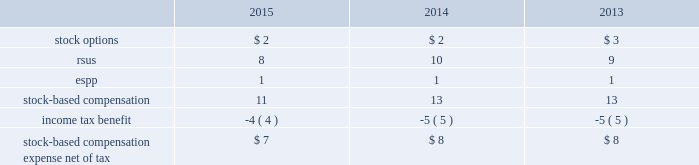Note 9 : stock based compensation the company has granted stock option and restricted stock unit ( 201crsus 201d ) awards to non-employee directors , officers and other key employees of the company pursuant to the terms of its 2007 omnibus equity compensation plan ( the 201c2007 plan 201d ) .
The total aggregate number of shares of common stock that may be issued under the 2007 plan is 15.5 .
As of december 31 , 2015 , 8.4 shares were available for grant under the 2007 plan .
Shares issued under the 2007 plan may be authorized-but-unissued shares of company stock or reacquired shares of company stock , including shares purchased by the company on the open market .
The company recognizes compensation expense for stock awards over the vesting period of the award .
The table presents stock-based compensation expense recorded in operation and maintenance expense in the accompanying consolidated statements of operations for the years ended december 31: .
There were no significant stock-based compensation costs capitalized during the years ended december 31 , 2015 , 2014 and 2013 .
The cost of services received from employees in exchange for the issuance of stock options and restricted stock awards is measured based on the grant date fair value of the awards issued .
The value of stock options and rsus awards at the date of the grant is amortized through expense over the three-year service period .
All awards granted in 2015 , 2014 and 2013 are classified as equity .
The company receives a tax deduction based on the intrinsic value of the award at the exercise date for stock options and the distribution date for rsus .
For each award , throughout the requisite service period , the company recognizes the tax benefits , which have been included in deferred income tax assets , related to compensation costs .
The tax deductions in excess of the benefits recorded throughout the requisite service period are recorded to common stockholders 2019 equity or the statement of operations and are presented in the financing section of the consolidated statements of cash flows .
The company stratified its grant populations and used historic employee turnover rates to estimate employee forfeitures .
The estimated rate is compared to the actual forfeitures at the end of the reporting period and adjusted as necessary .
Stock options in 2015 , 2014 and 2013 , the company granted non-qualified stock options to certain employees under the 2007 plan .
The stock options vest ratably over the three-year service period beginning on january 1 of the year of the grant .
These awards have no performance vesting conditions and the grant date fair value is amortized through expense over the requisite service period using the straight-line method and is included in operations and maintenance expense in the accompanying consolidated statements of operations. .
What was the rate of the income tax benefit based on the stock compensation? 
Rationale: the rate of the benefit is equal to the tax benefit divide by the total amount
Computations: (4 / 11)
Answer: 0.36364. Note 9 : stock based compensation the company has granted stock option and restricted stock unit ( 201crsus 201d ) awards to non-employee directors , officers and other key employees of the company pursuant to the terms of its 2007 omnibus equity compensation plan ( the 201c2007 plan 201d ) .
The total aggregate number of shares of common stock that may be issued under the 2007 plan is 15.5 .
As of december 31 , 2015 , 8.4 shares were available for grant under the 2007 plan .
Shares issued under the 2007 plan may be authorized-but-unissued shares of company stock or reacquired shares of company stock , including shares purchased by the company on the open market .
The company recognizes compensation expense for stock awards over the vesting period of the award .
The table presents stock-based compensation expense recorded in operation and maintenance expense in the accompanying consolidated statements of operations for the years ended december 31: .
There were no significant stock-based compensation costs capitalized during the years ended december 31 , 2015 , 2014 and 2013 .
The cost of services received from employees in exchange for the issuance of stock options and restricted stock awards is measured based on the grant date fair value of the awards issued .
The value of stock options and rsus awards at the date of the grant is amortized through expense over the three-year service period .
All awards granted in 2015 , 2014 and 2013 are classified as equity .
The company receives a tax deduction based on the intrinsic value of the award at the exercise date for stock options and the distribution date for rsus .
For each award , throughout the requisite service period , the company recognizes the tax benefits , which have been included in deferred income tax assets , related to compensation costs .
The tax deductions in excess of the benefits recorded throughout the requisite service period are recorded to common stockholders 2019 equity or the statement of operations and are presented in the financing section of the consolidated statements of cash flows .
The company stratified its grant populations and used historic employee turnover rates to estimate employee forfeitures .
The estimated rate is compared to the actual forfeitures at the end of the reporting period and adjusted as necessary .
Stock options in 2015 , 2014 and 2013 , the company granted non-qualified stock options to certain employees under the 2007 plan .
The stock options vest ratably over the three-year service period beginning on january 1 of the year of the grant .
These awards have no performance vesting conditions and the grant date fair value is amortized through expense over the requisite service period using the straight-line method and is included in operations and maintenance expense in the accompanying consolidated statements of operations. .
In 2018 , what percentage of stock-based compensation consisted of stock options? 
Computations: (2 / 11)
Answer: 0.18182. Note 9 : stock based compensation the company has granted stock option and restricted stock unit ( 201crsus 201d ) awards to non-employee directors , officers and other key employees of the company pursuant to the terms of its 2007 omnibus equity compensation plan ( the 201c2007 plan 201d ) .
The total aggregate number of shares of common stock that may be issued under the 2007 plan is 15.5 .
As of december 31 , 2015 , 8.4 shares were available for grant under the 2007 plan .
Shares issued under the 2007 plan may be authorized-but-unissued shares of company stock or reacquired shares of company stock , including shares purchased by the company on the open market .
The company recognizes compensation expense for stock awards over the vesting period of the award .
The table presents stock-based compensation expense recorded in operation and maintenance expense in the accompanying consolidated statements of operations for the years ended december 31: .
There were no significant stock-based compensation costs capitalized during the years ended december 31 , 2015 , 2014 and 2013 .
The cost of services received from employees in exchange for the issuance of stock options and restricted stock awards is measured based on the grant date fair value of the awards issued .
The value of stock options and rsus awards at the date of the grant is amortized through expense over the three-year service period .
All awards granted in 2015 , 2014 and 2013 are classified as equity .
The company receives a tax deduction based on the intrinsic value of the award at the exercise date for stock options and the distribution date for rsus .
For each award , throughout the requisite service period , the company recognizes the tax benefits , which have been included in deferred income tax assets , related to compensation costs .
The tax deductions in excess of the benefits recorded throughout the requisite service period are recorded to common stockholders 2019 equity or the statement of operations and are presented in the financing section of the consolidated statements of cash flows .
The company stratified its grant populations and used historic employee turnover rates to estimate employee forfeitures .
The estimated rate is compared to the actual forfeitures at the end of the reporting period and adjusted as necessary .
Stock options in 2015 , 2014 and 2013 , the company granted non-qualified stock options to certain employees under the 2007 plan .
The stock options vest ratably over the three-year service period beginning on january 1 of the year of the grant .
These awards have no performance vesting conditions and the grant date fair value is amortized through expense over the requisite service period using the straight-line method and is included in operations and maintenance expense in the accompanying consolidated statements of operations. .
As of december 31 . 2015 what was the % (  % ) of shares available for grant under the 2007 plan .? 
Rationale: the % available for grant is the ratio of the available amount to the amount authorized .
Computations: (8.4 / 15.5)
Answer: 0.54194. 